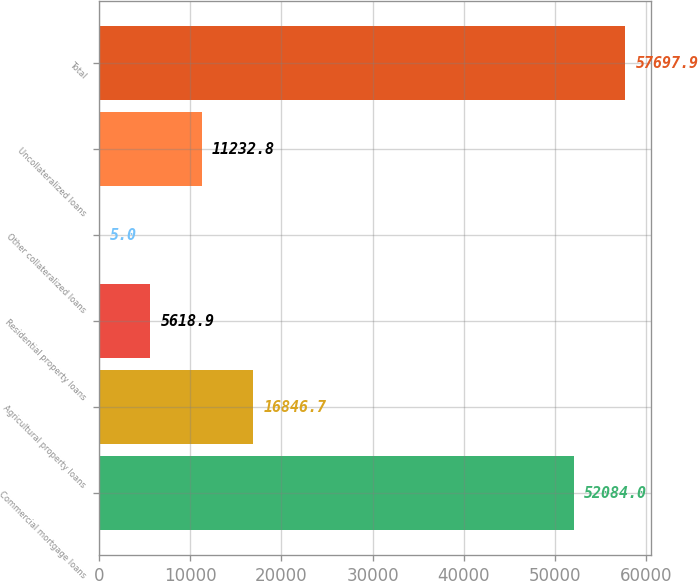Convert chart. <chart><loc_0><loc_0><loc_500><loc_500><bar_chart><fcel>Commercial mortgage loans<fcel>Agricultural property loans<fcel>Residential property loans<fcel>Other collateralized loans<fcel>Uncollateralized loans<fcel>Total<nl><fcel>52084<fcel>16846.7<fcel>5618.9<fcel>5<fcel>11232.8<fcel>57697.9<nl></chart> 